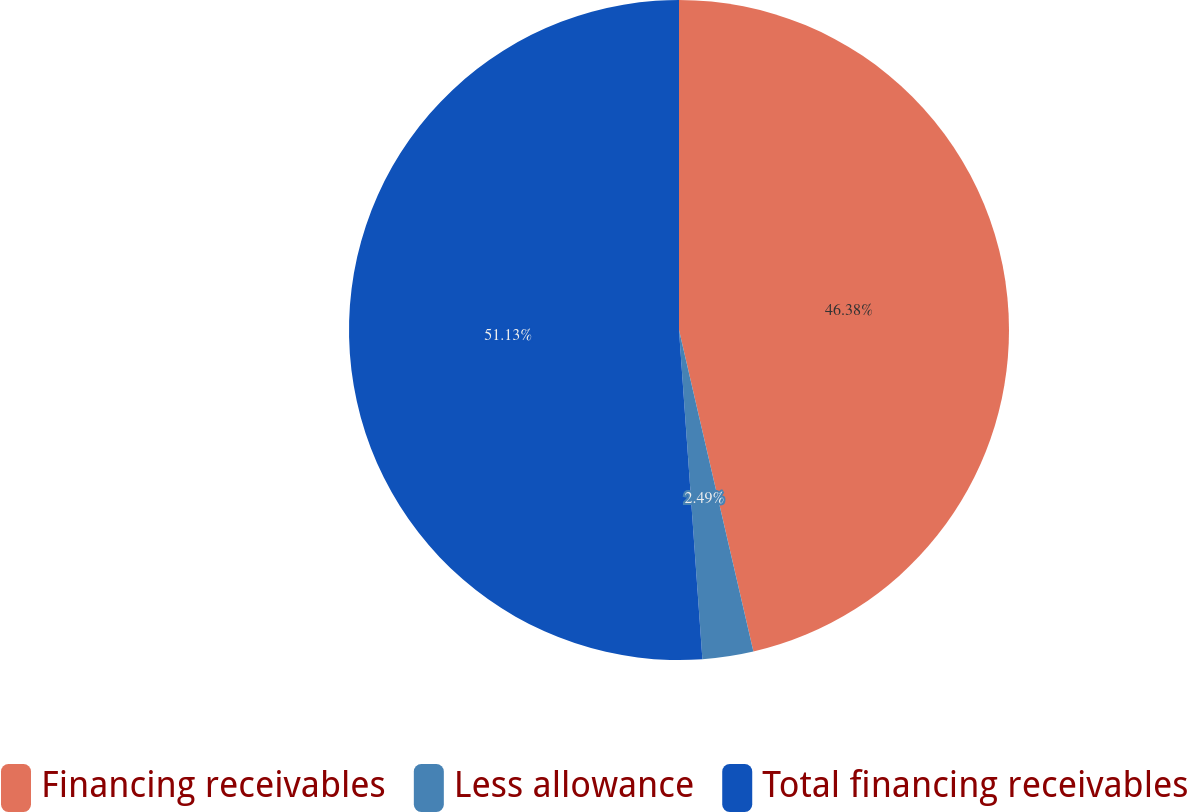<chart> <loc_0><loc_0><loc_500><loc_500><pie_chart><fcel>Financing receivables<fcel>Less allowance<fcel>Total financing receivables<nl><fcel>46.38%<fcel>2.49%<fcel>51.13%<nl></chart> 